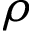Convert formula to latex. <formula><loc_0><loc_0><loc_500><loc_500>\rho</formula> 